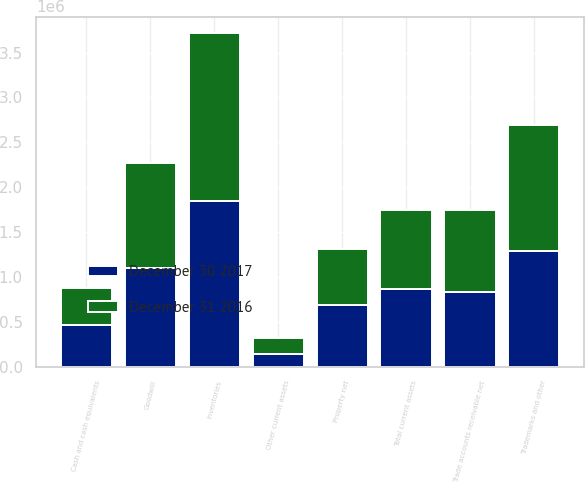Convert chart to OTSL. <chart><loc_0><loc_0><loc_500><loc_500><stacked_bar_chart><ecel><fcel>Cash and cash equivalents<fcel>Trade accounts receivable net<fcel>Inventories<fcel>Other current assets<fcel>Total current assets<fcel>Property net<fcel>Trademarks and other<fcel>Goodwill<nl><fcel>December 31 2016<fcel>421566<fcel>903318<fcel>1.87499e+06<fcel>186496<fcel>870121<fcel>623991<fcel>1.40286e+06<fcel>1.16701e+06<nl><fcel>December 30 2017<fcel>460245<fcel>836924<fcel>1.84056e+06<fcel>137535<fcel>870121<fcel>692464<fcel>1.28546e+06<fcel>1.09854e+06<nl></chart> 